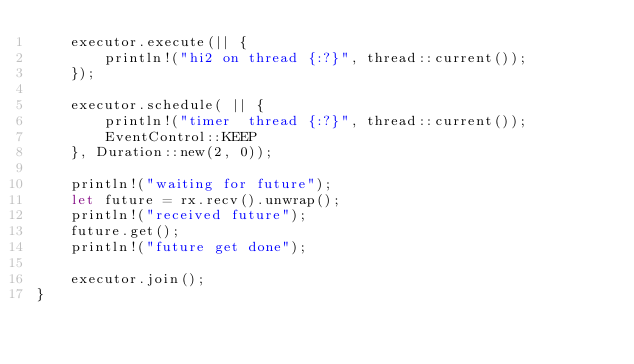<code> <loc_0><loc_0><loc_500><loc_500><_Rust_>    executor.execute(|| {
        println!("hi2 on thread {:?}", thread::current());
    });

    executor.schedule( || {
        println!("timer  thread {:?}", thread::current());
        EventControl::KEEP
    }, Duration::new(2, 0));

    println!("waiting for future");
    let future = rx.recv().unwrap();
    println!("received future");
    future.get();
    println!("future get done");
    
    executor.join();
}
</code> 